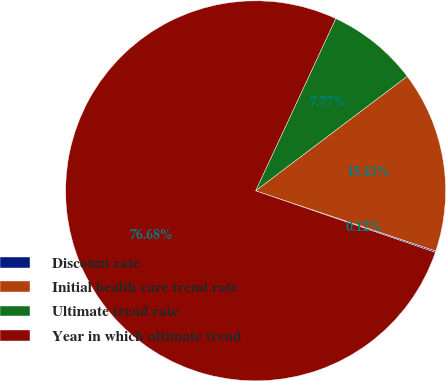Convert chart to OTSL. <chart><loc_0><loc_0><loc_500><loc_500><pie_chart><fcel>Discount rate<fcel>Initial health care trend rate<fcel>Ultimate trend rate<fcel>Year in which ultimate trend<nl><fcel>0.12%<fcel>15.43%<fcel>7.77%<fcel>76.68%<nl></chart> 